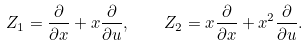Convert formula to latex. <formula><loc_0><loc_0><loc_500><loc_500>Z _ { 1 } = \frac { \partial } { \partial x } + x \frac { \partial } { \partial u } , \quad Z _ { 2 } = x \frac { \partial } { \partial x } + x ^ { 2 } \frac { \partial } { \partial u } .</formula> 